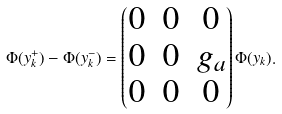Convert formula to latex. <formula><loc_0><loc_0><loc_500><loc_500>\Phi ( y _ { k } ^ { + } ) - \Phi ( y _ { k } ^ { - } ) = \begin{pmatrix} 0 & 0 & 0 \\ 0 & 0 & g _ { a } \\ 0 & 0 & 0 \end{pmatrix} \Phi ( y _ { k } ) .</formula> 